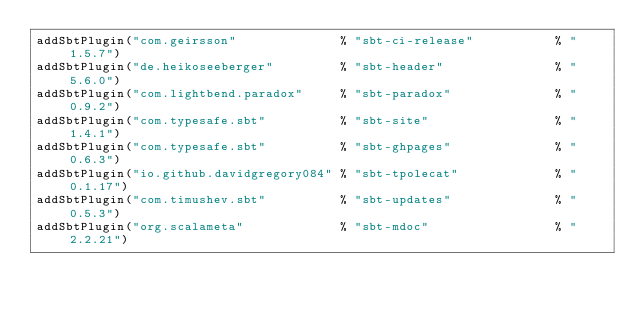Convert code to text. <code><loc_0><loc_0><loc_500><loc_500><_Scala_>addSbtPlugin("com.geirsson"              % "sbt-ci-release"           % "1.5.7")
addSbtPlugin("de.heikoseeberger"         % "sbt-header"               % "5.6.0")
addSbtPlugin("com.lightbend.paradox"     % "sbt-paradox"              % "0.9.2")
addSbtPlugin("com.typesafe.sbt"          % "sbt-site"                 % "1.4.1")
addSbtPlugin("com.typesafe.sbt"          % "sbt-ghpages"              % "0.6.3")
addSbtPlugin("io.github.davidgregory084" % "sbt-tpolecat"             % "0.1.17")
addSbtPlugin("com.timushev.sbt"          % "sbt-updates"              % "0.5.3")
addSbtPlugin("org.scalameta"             % "sbt-mdoc"                 % "2.2.21")</code> 